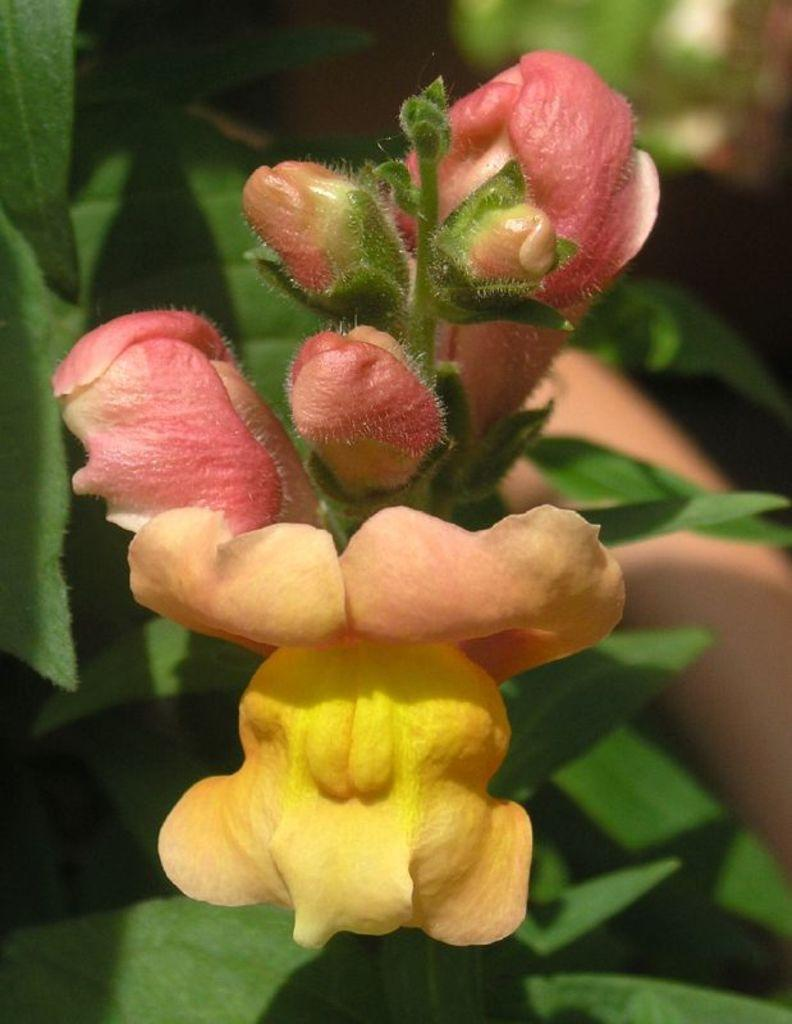What is the main subject in the center of the image? There are flowers in the center of the image. What other type of plant can be seen at the bottom of the image? There are plants at the bottom of the image. What type of honey can be seen dripping from the flowers in the image? There is no honey present in the image; it only features flowers and plants. 